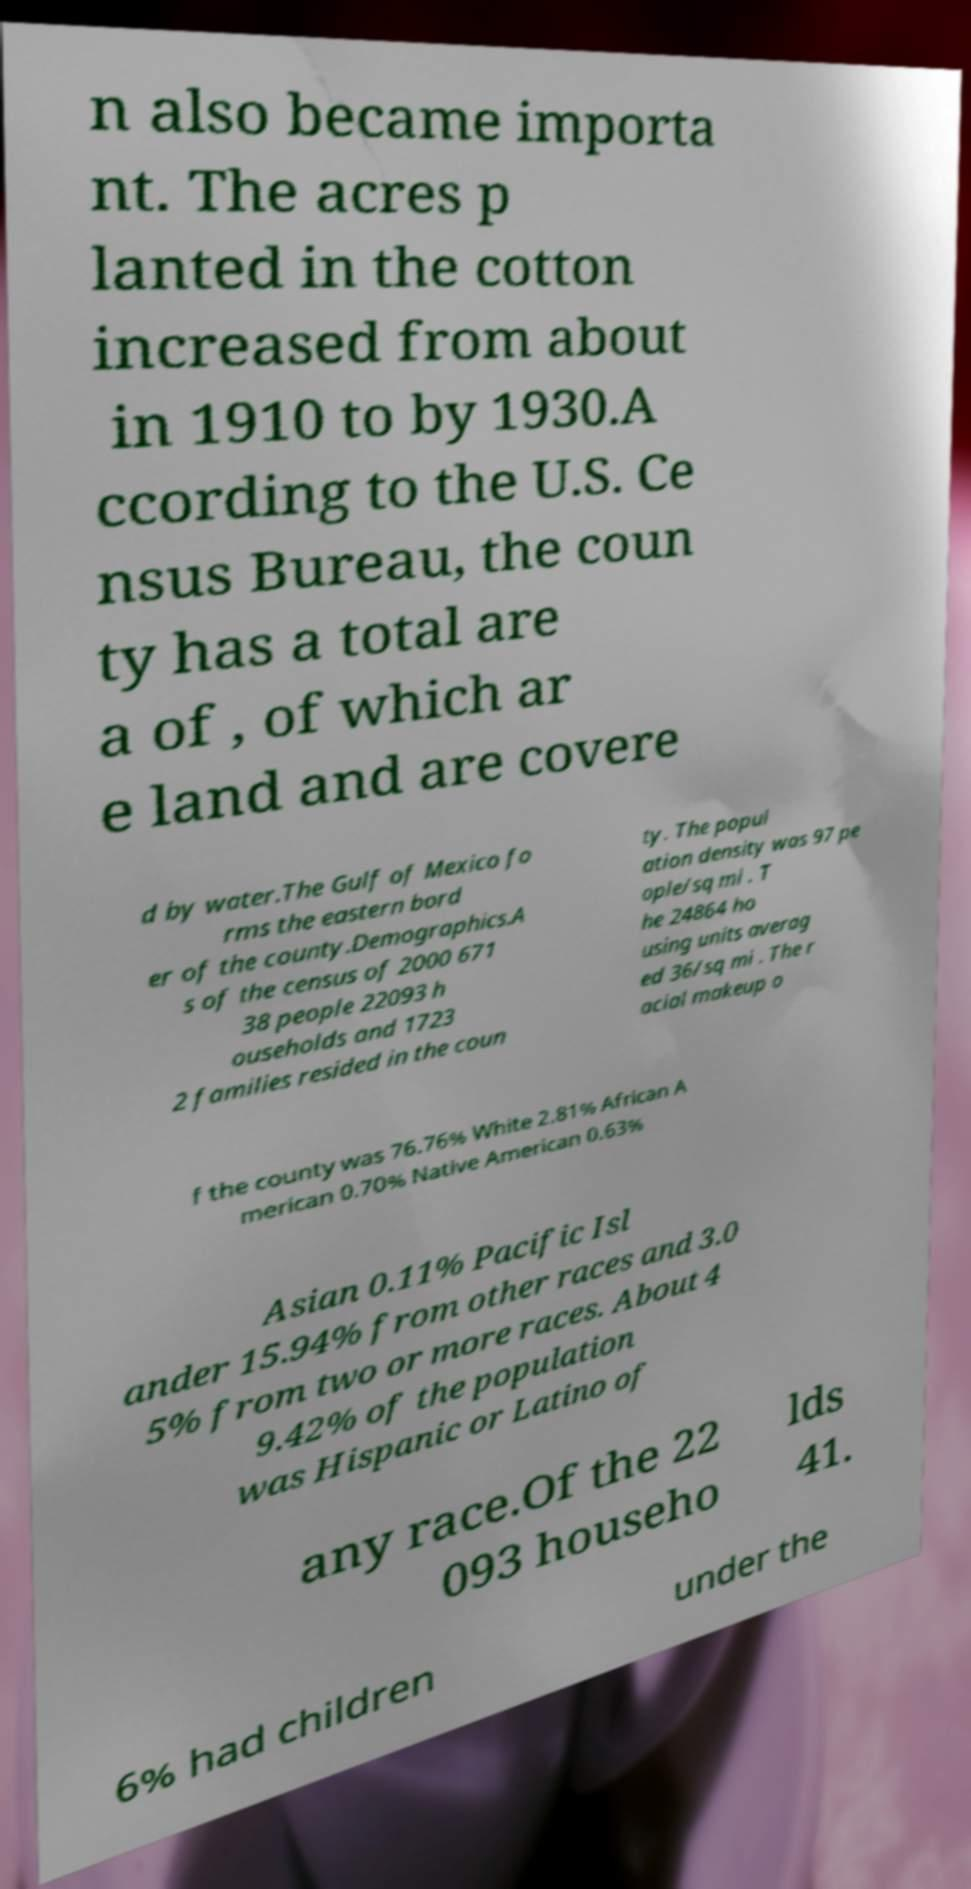Can you accurately transcribe the text from the provided image for me? n also became importa nt. The acres p lanted in the cotton increased from about in 1910 to by 1930.A ccording to the U.S. Ce nsus Bureau, the coun ty has a total are a of , of which ar e land and are covere d by water.The Gulf of Mexico fo rms the eastern bord er of the county.Demographics.A s of the census of 2000 671 38 people 22093 h ouseholds and 1723 2 families resided in the coun ty. The popul ation density was 97 pe ople/sq mi . T he 24864 ho using units averag ed 36/sq mi . The r acial makeup o f the county was 76.76% White 2.81% African A merican 0.70% Native American 0.63% Asian 0.11% Pacific Isl ander 15.94% from other races and 3.0 5% from two or more races. About 4 9.42% of the population was Hispanic or Latino of any race.Of the 22 093 househo lds 41. 6% had children under the 